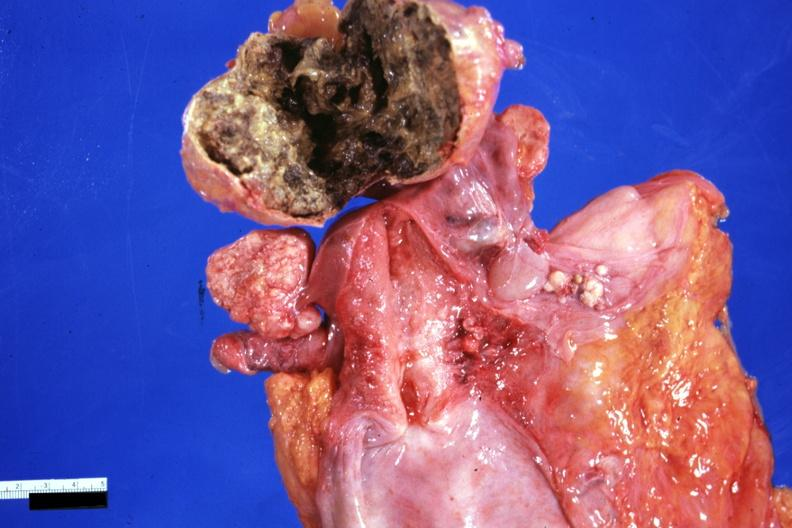does this image show necrotic central mass with thin fibrous capsule not all that typical 91yo?
Answer the question using a single word or phrase. Yes 